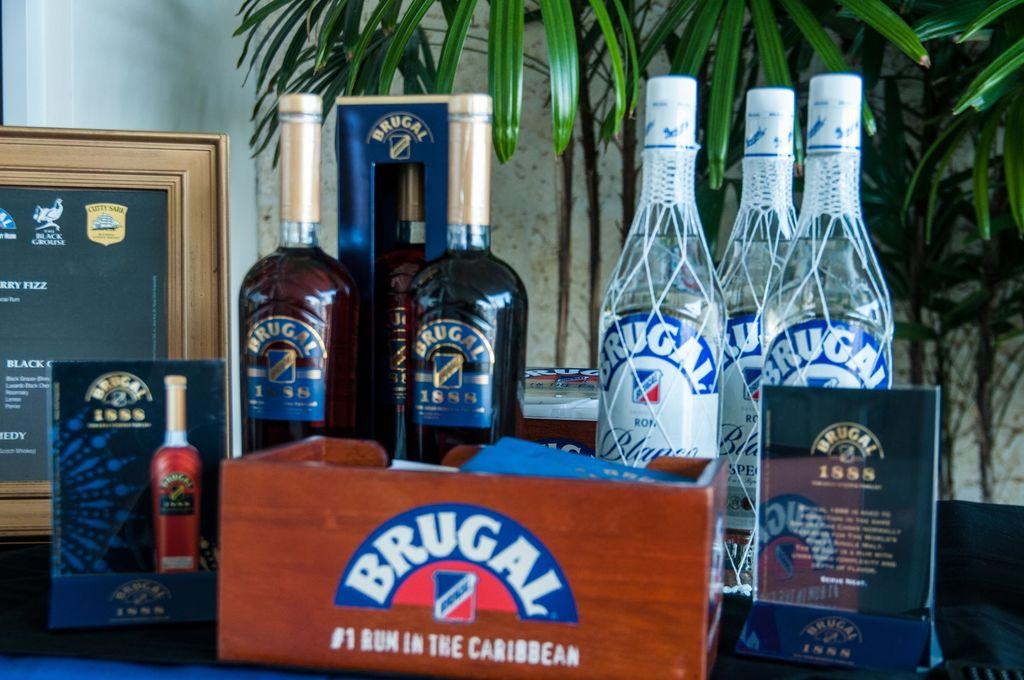<image>
Present a compact description of the photo's key features. A display of Brugal rum claims that it is the #1 rum in the Caribbean. 